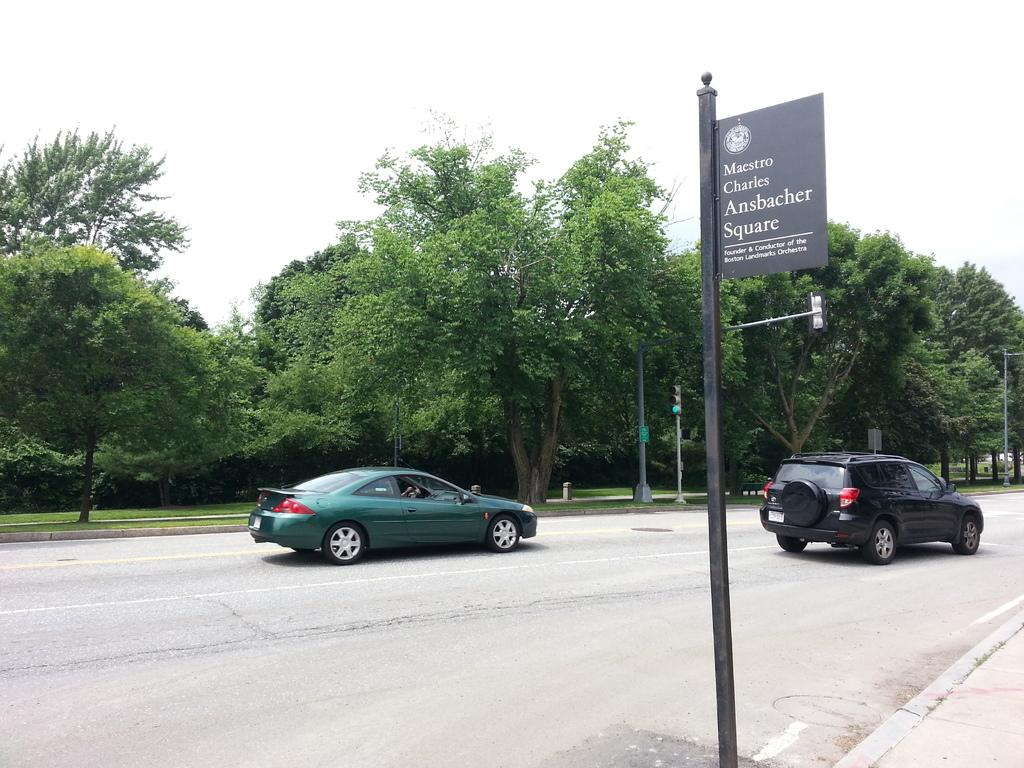What can be seen on the road in the image? There are vehicles on the road in the image. What is attached to a pole in the image? A board is attached to a pole in the image. What type of natural scenery is visible in the background? There are trees in the background of the image. What other structures can be seen in the background? There is a signal light pole in the background. How many cows are grazing in the image? There are no cows present in the image. What color is the shirt worn by the tree in the image? Trees do not wear shirts, and there are no people or animals wearing shirts in the image. 